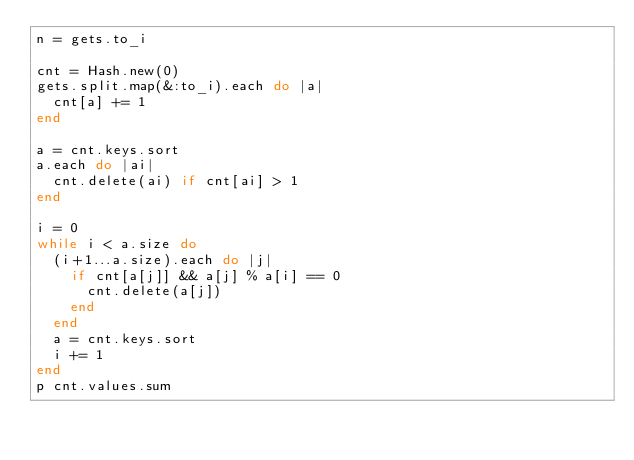Convert code to text. <code><loc_0><loc_0><loc_500><loc_500><_Ruby_>n = gets.to_i

cnt = Hash.new(0)
gets.split.map(&:to_i).each do |a|
  cnt[a] += 1
end

a = cnt.keys.sort
a.each do |ai|
  cnt.delete(ai) if cnt[ai] > 1
end

i = 0
while i < a.size do
  (i+1...a.size).each do |j|
    if cnt[a[j]] && a[j] % a[i] == 0
      cnt.delete(a[j])
    end
  end
  a = cnt.keys.sort
  i += 1
end
p cnt.values.sum
</code> 